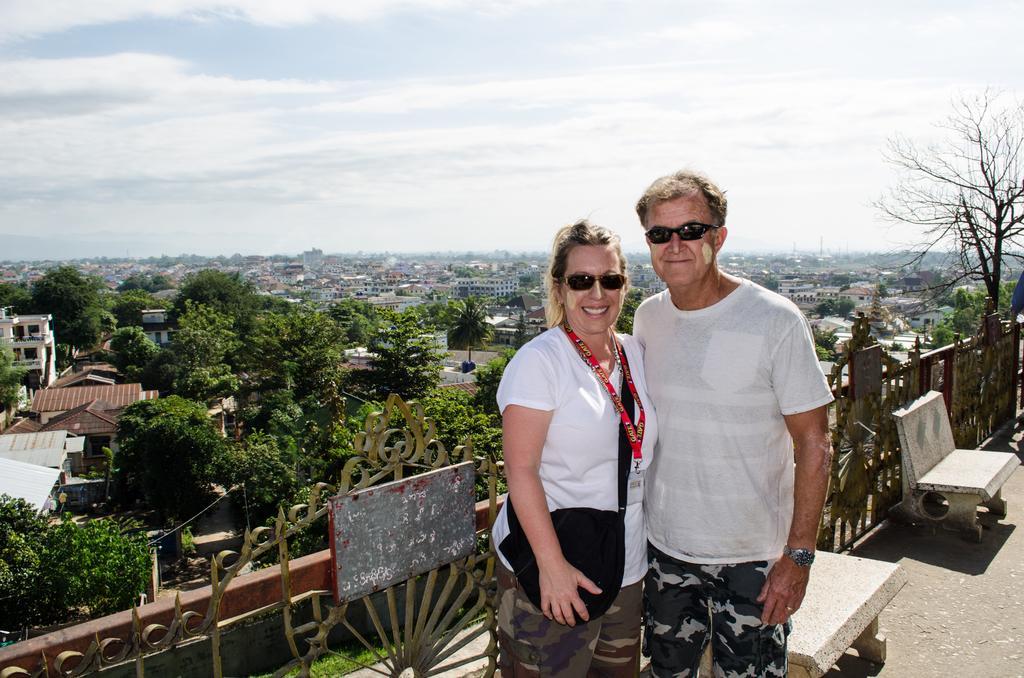Can you describe this image briefly? In this image I can see two people standing. These people are wearing the white color shirt and goggles. One person is wearing the black color bag. To the side I can see few benches and the railing. In the background there are many trees and the buildings. I can also see the clouds and the sky in the back. 